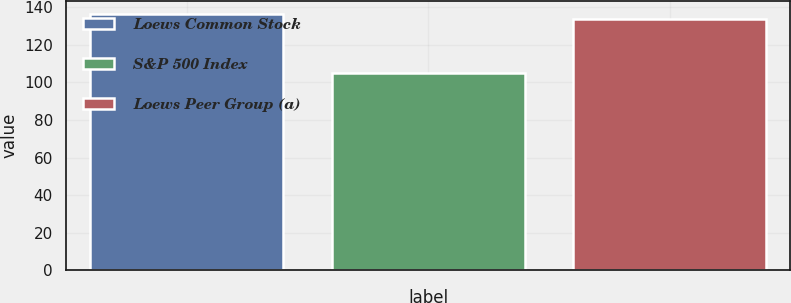<chart> <loc_0><loc_0><loc_500><loc_500><bar_chart><fcel>Loews Common Stock<fcel>S&P 500 Index<fcel>Loews Peer Group (a)<nl><fcel>136.69<fcel>104.91<fcel>133.59<nl></chart> 